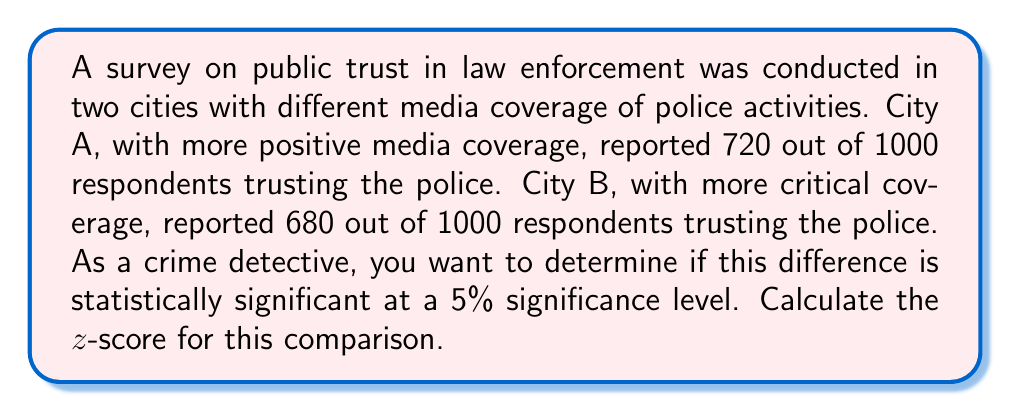Help me with this question. To determine if the difference in public trust between the two cities is statistically significant, we'll use a two-proportion z-test. Here's the step-by-step process:

1. Define the parameters:
   $p_A = 720/1000 = 0.72$ (proportion in City A)
   $p_B = 680/1000 = 0.68$ (proportion in City B)
   $n_A = n_B = 1000$ (sample size for each city)

2. Calculate the pooled proportion:
   $$p = \frac{X_A + X_B}{n_A + n_B} = \frac{720 + 680}{1000 + 1000} = \frac{1400}{2000} = 0.70$$

3. Calculate the standard error:
   $$SE = \sqrt{p(1-p)(\frac{1}{n_A} + \frac{1}{n_B})}$$
   $$SE = \sqrt{0.70(1-0.70)(\frac{1}{1000} + \frac{1}{1000})}$$
   $$SE = \sqrt{0.21 \cdot 0.002} = \sqrt{0.00042} \approx 0.0205$$

4. Calculate the z-score:
   $$z = \frac{p_A - p_B}{SE} = \frac{0.72 - 0.68}{0.0205} \approx 1.9512$$

The calculated z-score is approximately 1.9512. To determine statistical significance at the 5% level, compare this to the critical z-value of ±1.96 for a two-tailed test.
Answer: $z \approx 1.9512$ 